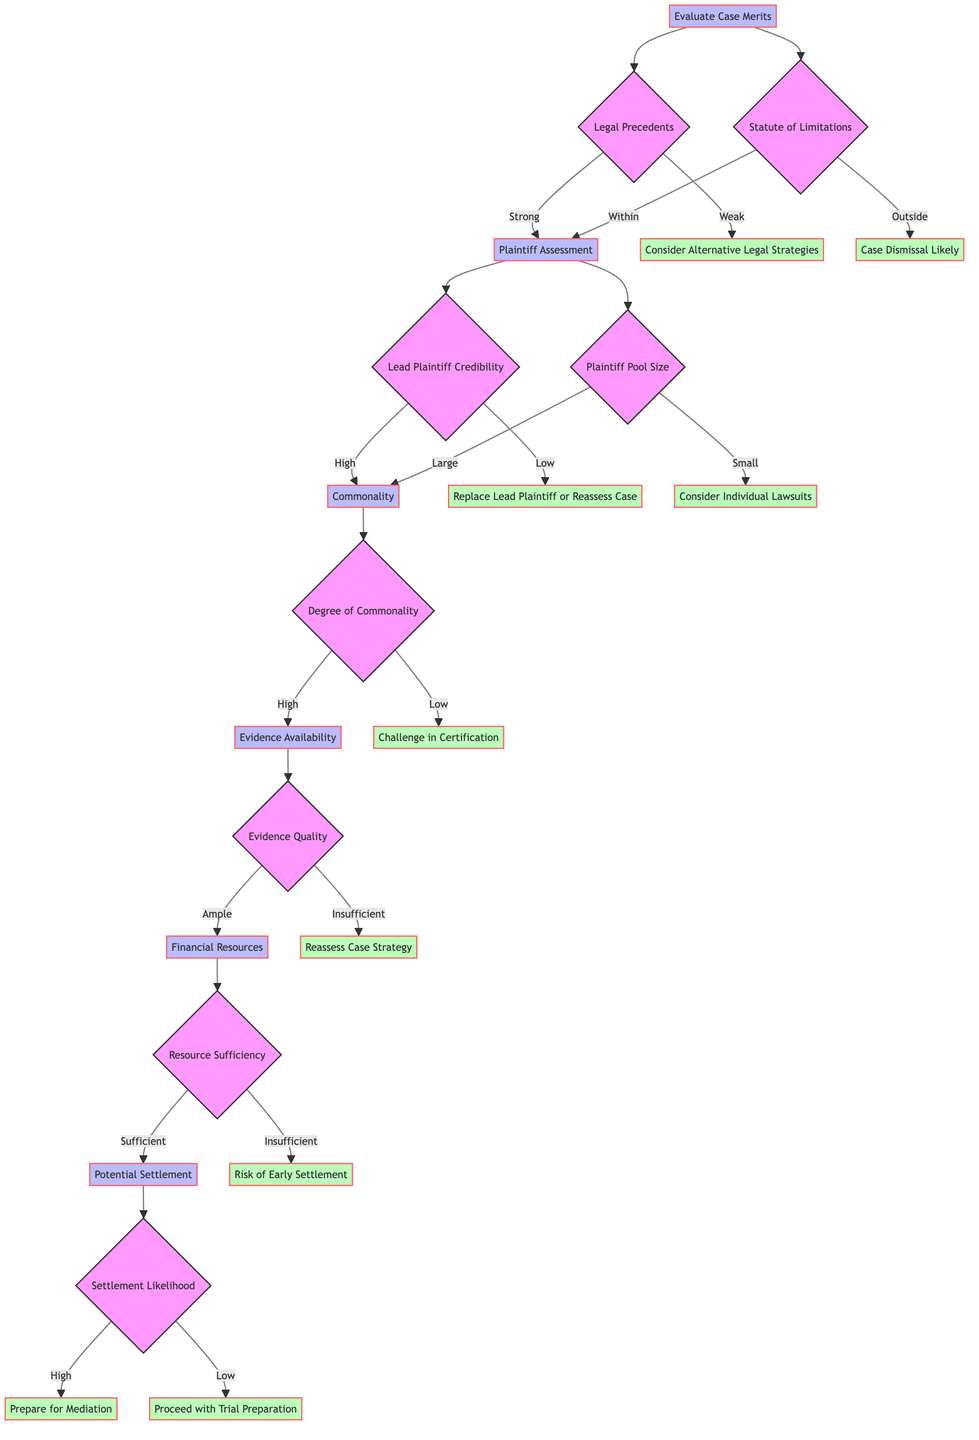What is the first step in the decision tree? The decision tree starts with the "Evaluate Case Merits" node, which is the initial step before moving onto subsequent considerations.
Answer: Evaluate Case Merits How many outcomes follow the "Legal Precedents" decision? From the "Legal Precedents" node, there are two outcomes: "Strong" leading to "Plaintiff Assessment" and "Weak" leading to "Consider Alternative Legal Strategies."
Answer: Two What happens if the statute of limitations is outside the acceptable range? If the statute of limitations is "Outside," the decision tree indicates a "Case Dismissal Likely" outcome, suggesting the claims cannot proceed.
Answer: Case Dismissal Likely What does a "High Degree of Commonality" lead to? A "High Degree of Commonality" leads to the next node, "Evidence Availability," indicating that the claims share significant legal or factual issues.
Answer: Evidence Availability If the lead plaintiff has low credibility, what is the recommended action? If the lead plaintiff has "Low Credibility," the recommended action is to "Replace Lead Plaintiff or Reassess Case," suggesting the need for a stronger representative.
Answer: Replace Lead Plaintiff or Reassess Case What are the two potential outcomes after assessing financial resources? The two outcomes following the "Financial Resources" assessment are "Sufficient Resources" leading to "Potential Settlement," and "Insufficient Resources" leading to "Risk of Early Settlement."
Answer: Sufficient Resources and Insufficient Resources What is the final decision node in the diagram? The final decision node in the diagram is "Settlement Likelihood," where the evaluation of settlement options is made.
Answer: Settlement Likelihood Under what condition would you risk an early settlement? You would risk an "Early Settlement" if there are "Insufficient Resources" to sustain prolonged litigation, indicating financial limitations.
Answer: Insufficient Resources What is the consequence of a low degree of commonality? A "Low Degree of Commonality" results in a "Challenge in Certification," indicating difficulties in proceeding with the class action certification process.
Answer: Challenge in Certification 